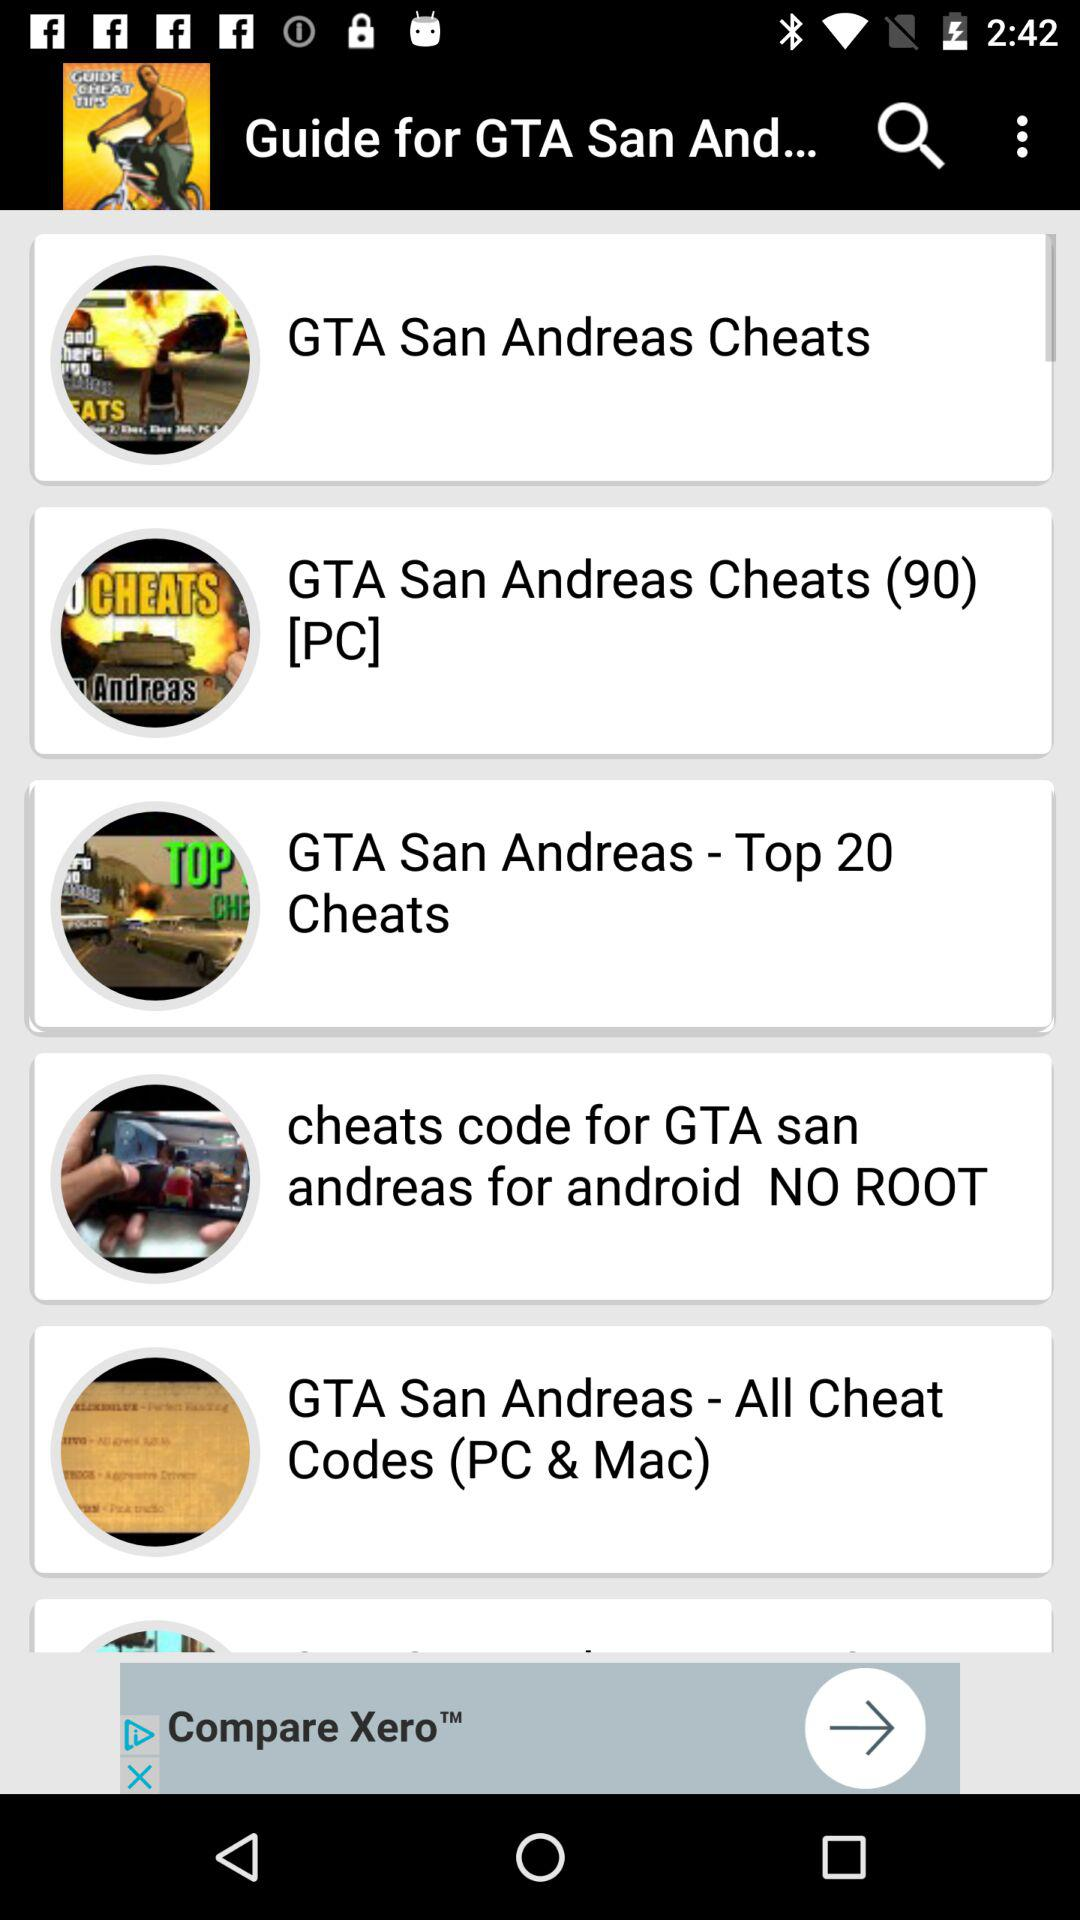What is the count of GTA San Andreas Cheats for PC? The count is 90. 